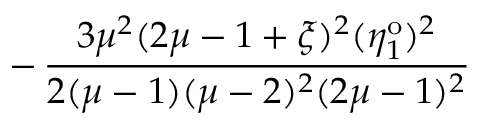Convert formula to latex. <formula><loc_0><loc_0><loc_500><loc_500>- \, \frac { 3 \mu ^ { 2 } ( 2 \mu - 1 + \xi ) ^ { 2 } ( \eta _ { 1 } ^ { o } ) ^ { 2 } } { 2 ( \mu - 1 ) ( \mu - 2 ) ^ { 2 } ( 2 \mu - 1 ) ^ { 2 } }</formula> 